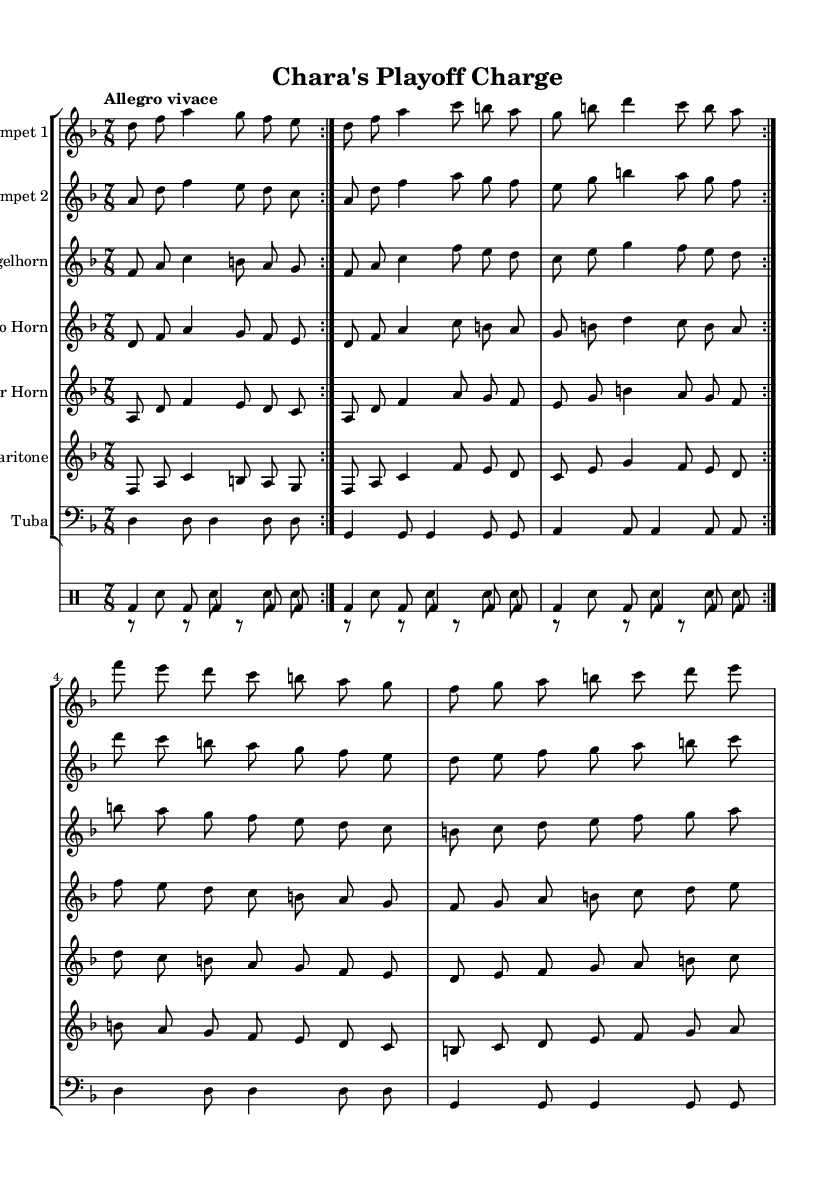What is the key signature of this music? The key signature indicated at the beginning of the score shows one flat, which means it is in the key of D minor.
Answer: D minor What is the time signature of this piece? The time signature shown at the beginning is 7/8, indicating that there are seven beats in a measure, and the eighth note gets one beat.
Answer: 7/8 What is the tempo marking for this composition? The tempo marking at the beginning states "Allegro vivace," which means it should be played quickly and lively, typically around 120-168 beats per minute.
Answer: Allegro vivace Which instruments are featured in this brass band composition? The score includes Trumpet 1, Trumpet 2, Flugelhorn, Alto Horn, Tenor Horn, Baritone, and Tuba, indicating a rich brass ensemble sound.
Answer: Trumpet 1, Trumpet 2, Flugelhorn, Alto Horn, Tenor Horn, Baritone, Tuba How many times is the main theme repeated throughout the piece? The main musical themes indicated in each instrumental line have a repeat marker (volta) written twice, suggesting that each section of music is played two times before moving forward.
Answer: 2 What type of music style does this composition represent? The lively rhythms and instrumentation suggest a Balkan brass band style, which is known for its energetic and festive nature, often used to celebrate events like playoff seasons.
Answer: Balkan brass band 